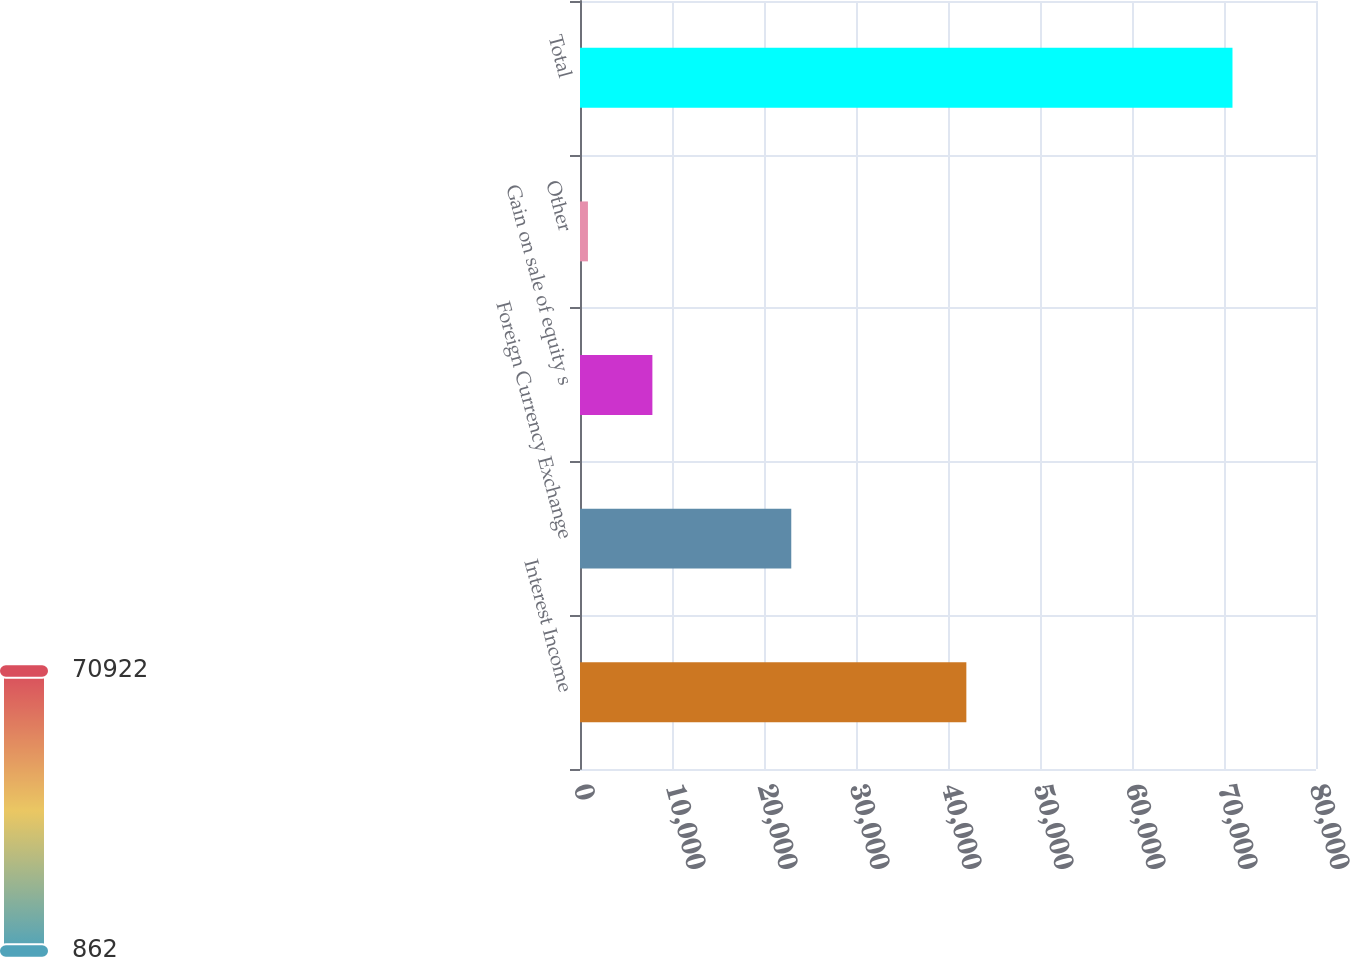<chart> <loc_0><loc_0><loc_500><loc_500><bar_chart><fcel>Interest Income<fcel>Foreign Currency Exchange<fcel>Gain on sale of equity s<fcel>Other<fcel>Total<nl><fcel>41995<fcel>22964<fcel>7868<fcel>862<fcel>70922<nl></chart> 